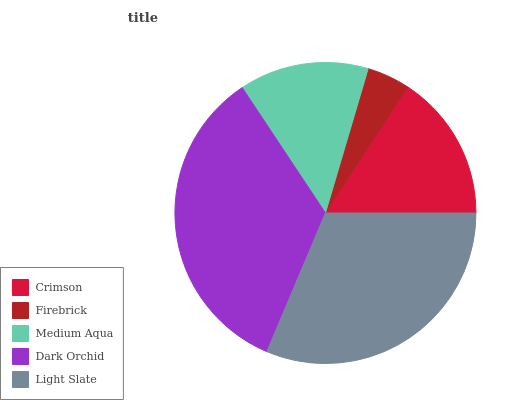Is Firebrick the minimum?
Answer yes or no. Yes. Is Dark Orchid the maximum?
Answer yes or no. Yes. Is Medium Aqua the minimum?
Answer yes or no. No. Is Medium Aqua the maximum?
Answer yes or no. No. Is Medium Aqua greater than Firebrick?
Answer yes or no. Yes. Is Firebrick less than Medium Aqua?
Answer yes or no. Yes. Is Firebrick greater than Medium Aqua?
Answer yes or no. No. Is Medium Aqua less than Firebrick?
Answer yes or no. No. Is Crimson the high median?
Answer yes or no. Yes. Is Crimson the low median?
Answer yes or no. Yes. Is Light Slate the high median?
Answer yes or no. No. Is Light Slate the low median?
Answer yes or no. No. 